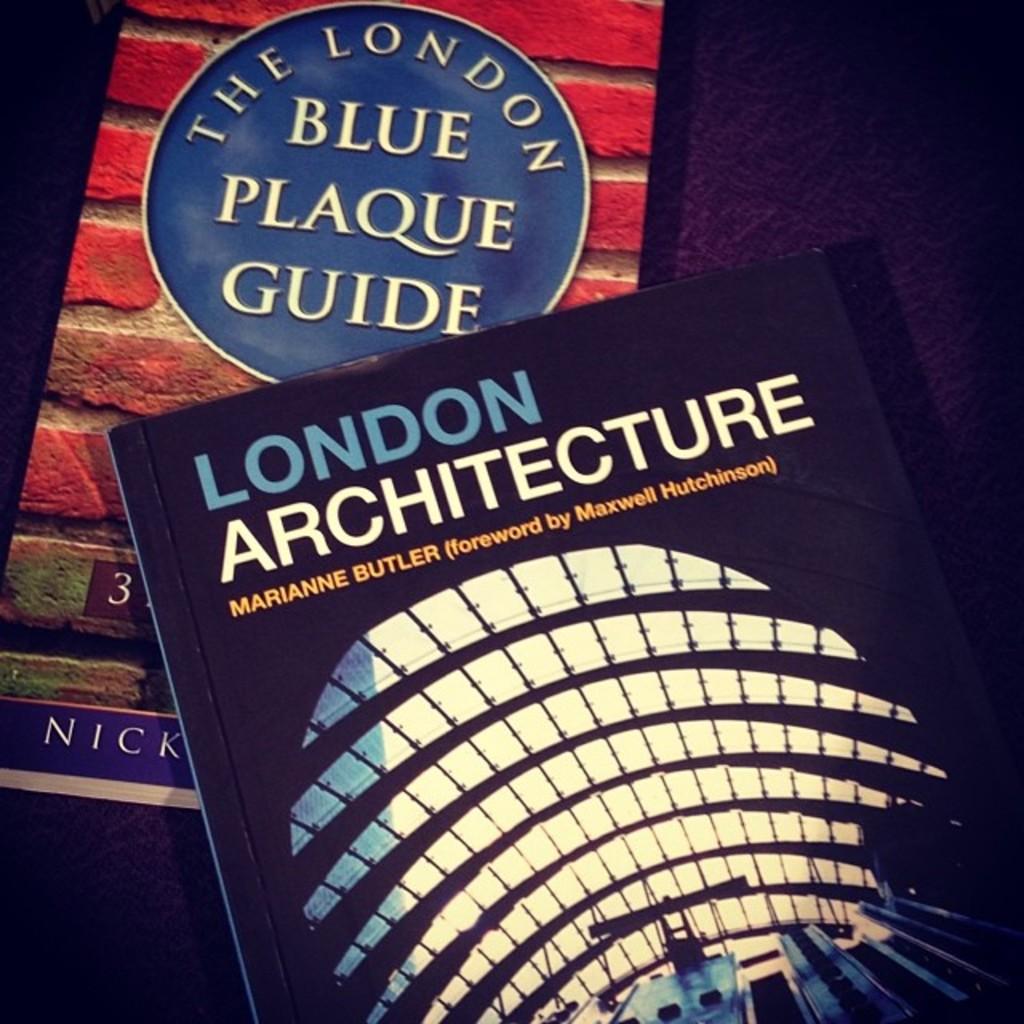Is there a book on london architecture?
Your answer should be very brief. Yes. Name the book on the bottom?
Your answer should be very brief. London architecture. 